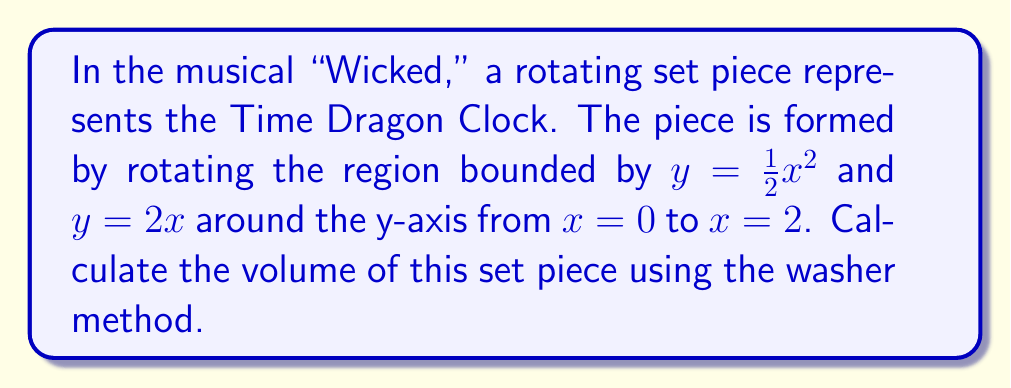Give your solution to this math problem. To solve this problem using the washer method, we'll follow these steps:

1) The washer method formula for volume when rotating around the y-axis is:

   $$V = \pi \int_a^b [(R(y))^2 - (r(y))^2] dy$$

   where $R(y)$ is the outer function and $r(y)$ is the inner function.

2) We need to express $x$ in terms of $y$ for both functions:

   For $y = \frac{1}{2}x^2$, we get $x = \sqrt{2y}$ (outer function)
   For $y = 2x$, we get $x = \frac{1}{2}y$ (inner function)

3) Now we can set up our integral:

   $$V = \pi \int_0^4 [(\sqrt{2y})^2 - (\frac{1}{2}y)^2] dy$$

4) Simplify the integrand:

   $$V = \pi \int_0^4 [2y - \frac{1}{4}y^2] dy$$

5) Integrate:

   $$V = \pi [\frac{2y^2}{2} - \frac{1}{12}y^3]_0^4$$

6) Evaluate the integral:

   $$V = \pi [(16 - \frac{64}{3}) - (0 - 0)]$$
   $$V = \pi [16 - \frac{64}{3}]$$
   $$V = \pi [\frac{48}{3} - \frac{64}{3}]$$
   $$V = \pi [\frac{-16}{3}]$$

7) Simplify:

   $$V = -\frac{16\pi}{3}$$

The negative sign indicates that we've calculated the volume in the wrong direction. We need to take the absolute value.
Answer: $$V = \frac{16\pi}{3} \approx 16.76 \text{ cubic units}$$ 